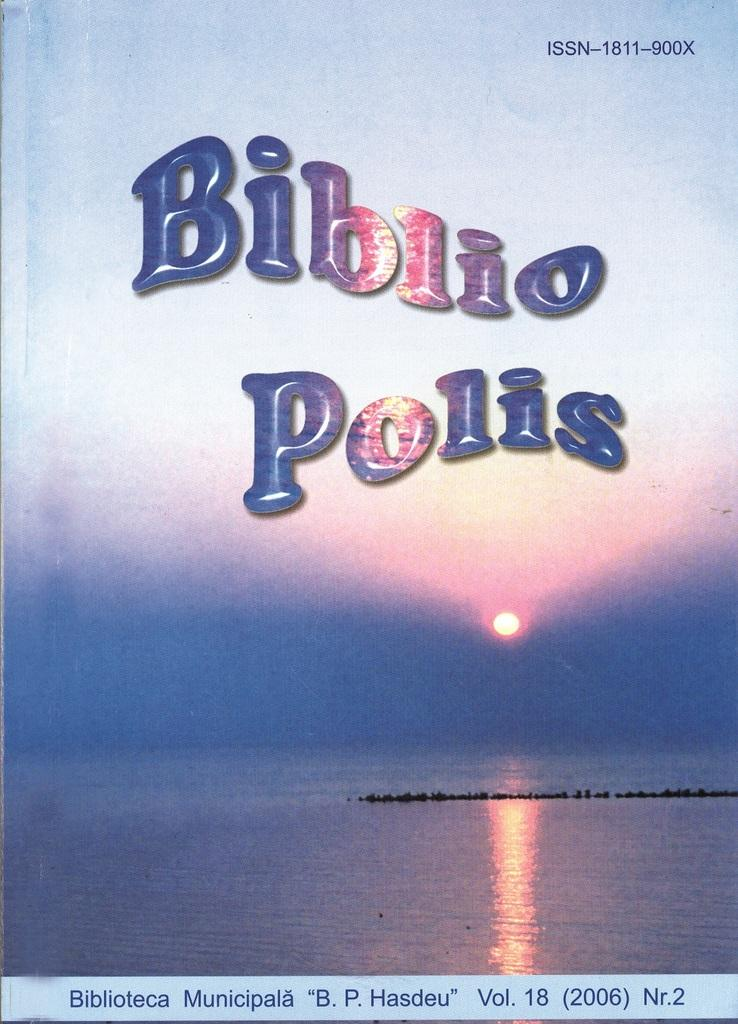<image>
Give a short and clear explanation of the subsequent image. A Biblio Polio textbook shows a body of water with a sun in the distance. 